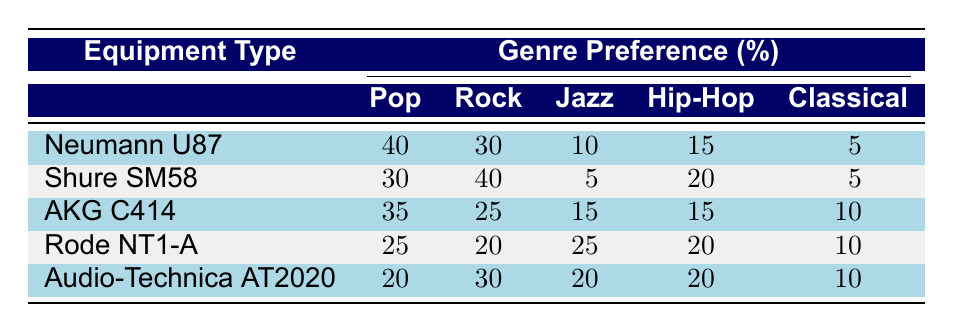What is the genre preference percentage for Pop when using the Neumann U87? The table shows that the genre preference for Pop using the Neumann U87 is 40%.
Answer: 40% What equipment type has the highest genre preference for Rock? The highest percentage for Rock is 40%, which corresponds to the Shure SM58 according to the table.
Answer: Shure SM58 Is the genre preference for Jazz higher with the Rode NT1-A compared to the Audio-Technica AT2020? The Rode NT1-A has a Jazz preference of 25%, while the Audio-Technica AT2020 has a Jazz preference of 20%. Since 25% is greater than 20%, the Rode NT1-A has a higher preference for Jazz.
Answer: Yes What is the total genre preference percentage for Hip-Hop across all equipment types? To find the total for Hip-Hop, we add the percentages: 15 (Neumann U87) + 20 (Shure SM58) + 15 (AKG C414) + 20 (Rode NT1-A) + 20 (Audio-Technica AT2020) = 90%.
Answer: 90% Which recording equipment type shows the lowest preference for Classical? Looking at the table, both Neumann U87 and Shure SM58 show a Classical preference of 5%, which is the lowest across all equipment types.
Answer: Neumann U87 and Shure SM58 What is the difference in Pop genre preference between the Neumann U87 and the Rode NT1-A? The Neumann U87 has a Pop preference of 40%, while the Rode NT1-A has a preference of 25%. The difference is 40 - 25 = 15%.
Answer: 15% Does any type of recording equipment show an equal preference between Rock and Classical? The table shows that no equipment type has the same percentage for both Rock and Classical, as the Rock preferences are higher than the Classical preferences for all equipment types.
Answer: No What is the average genre preference for Jazz among all the equipment types listed? The Jazz preferences are 10 (Neumann U87) + 5 (Shure SM58) + 15 (AKG C414) + 25 (Rode NT1-A) + 20 (Audio-Technica AT2020) = 75%. The average is 75% / 5 = 15%.
Answer: 15% 